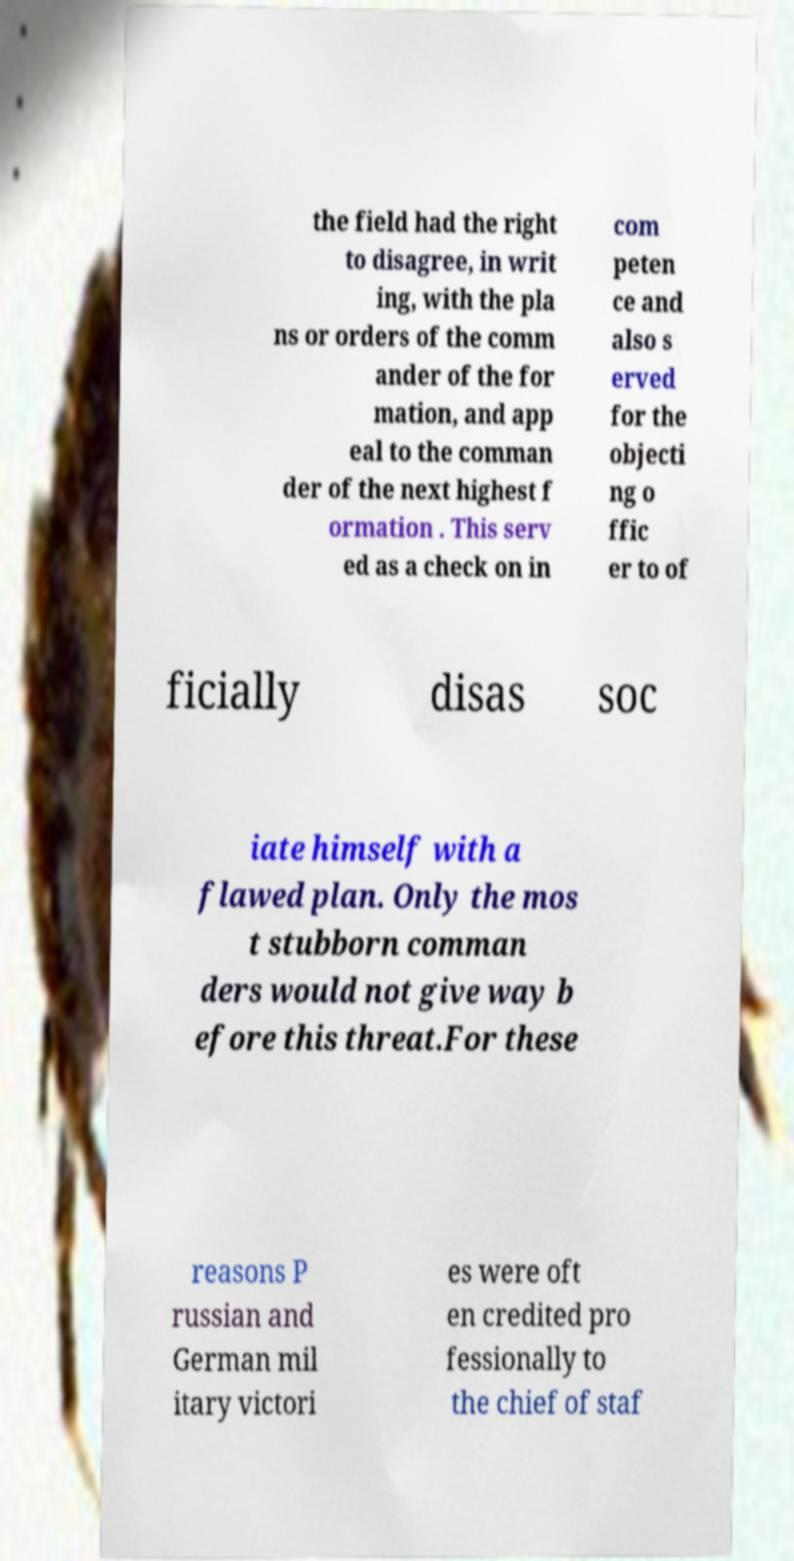There's text embedded in this image that I need extracted. Can you transcribe it verbatim? the field had the right to disagree, in writ ing, with the pla ns or orders of the comm ander of the for mation, and app eal to the comman der of the next highest f ormation . This serv ed as a check on in com peten ce and also s erved for the objecti ng o ffic er to of ficially disas soc iate himself with a flawed plan. Only the mos t stubborn comman ders would not give way b efore this threat.For these reasons P russian and German mil itary victori es were oft en credited pro fessionally to the chief of staf 